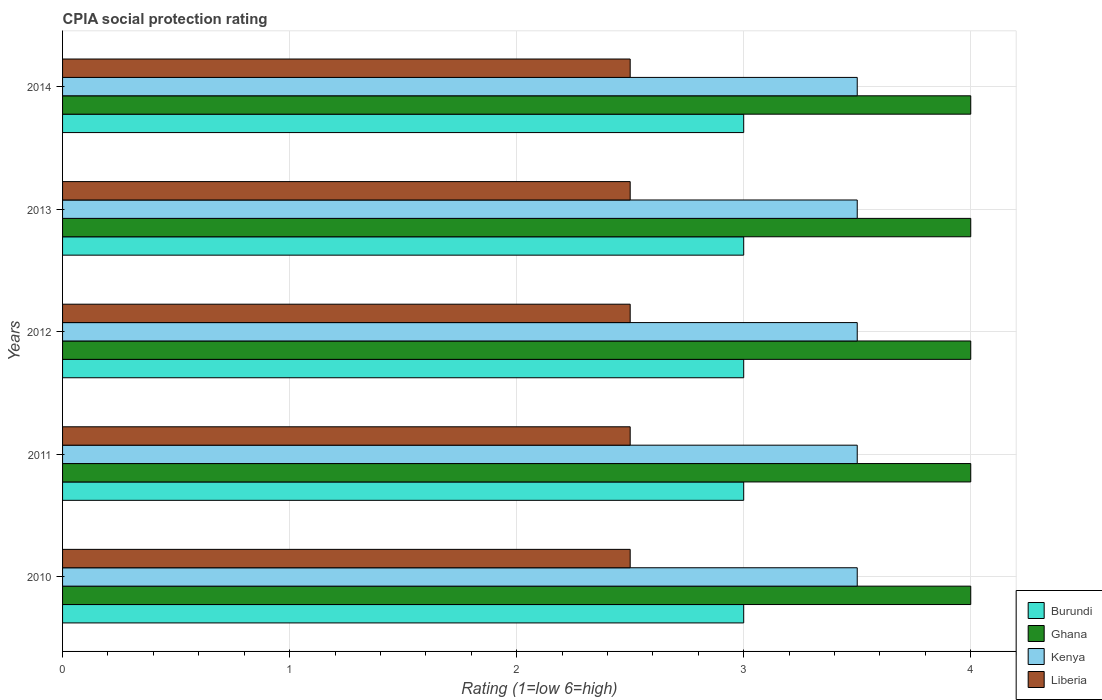How many different coloured bars are there?
Ensure brevity in your answer.  4. How many groups of bars are there?
Make the answer very short. 5. Are the number of bars per tick equal to the number of legend labels?
Make the answer very short. Yes. Are the number of bars on each tick of the Y-axis equal?
Offer a very short reply. Yes. How many bars are there on the 1st tick from the top?
Make the answer very short. 4. Across all years, what is the maximum CPIA rating in Ghana?
Give a very brief answer. 4. In which year was the CPIA rating in Liberia maximum?
Offer a very short reply. 2010. What is the total CPIA rating in Kenya in the graph?
Your answer should be very brief. 17.5. What is the difference between the CPIA rating in Kenya in 2011 and the CPIA rating in Ghana in 2014?
Your answer should be compact. -0.5. What is the average CPIA rating in Burundi per year?
Keep it short and to the point. 3. In how many years, is the CPIA rating in Ghana greater than 2.4 ?
Your answer should be compact. 5. What is the difference between the highest and the second highest CPIA rating in Ghana?
Make the answer very short. 0. What is the difference between the highest and the lowest CPIA rating in Ghana?
Keep it short and to the point. 0. In how many years, is the CPIA rating in Kenya greater than the average CPIA rating in Kenya taken over all years?
Your answer should be very brief. 0. Is the sum of the CPIA rating in Kenya in 2012 and 2013 greater than the maximum CPIA rating in Liberia across all years?
Keep it short and to the point. Yes. What does the 2nd bar from the top in 2011 represents?
Ensure brevity in your answer.  Kenya. What does the 1st bar from the bottom in 2011 represents?
Offer a very short reply. Burundi. How many bars are there?
Provide a succinct answer. 20. How many years are there in the graph?
Offer a very short reply. 5. Does the graph contain any zero values?
Provide a succinct answer. No. Does the graph contain grids?
Your response must be concise. Yes. How many legend labels are there?
Make the answer very short. 4. How are the legend labels stacked?
Ensure brevity in your answer.  Vertical. What is the title of the graph?
Make the answer very short. CPIA social protection rating. What is the label or title of the X-axis?
Your answer should be compact. Rating (1=low 6=high). What is the label or title of the Y-axis?
Offer a terse response. Years. What is the Rating (1=low 6=high) of Burundi in 2010?
Give a very brief answer. 3. What is the Rating (1=low 6=high) in Ghana in 2010?
Offer a terse response. 4. What is the Rating (1=low 6=high) of Kenya in 2010?
Give a very brief answer. 3.5. What is the Rating (1=low 6=high) in Burundi in 2011?
Your response must be concise. 3. What is the Rating (1=low 6=high) in Ghana in 2011?
Your response must be concise. 4. What is the Rating (1=low 6=high) of Ghana in 2012?
Ensure brevity in your answer.  4. What is the Rating (1=low 6=high) of Kenya in 2013?
Keep it short and to the point. 3.5. What is the Rating (1=low 6=high) in Liberia in 2013?
Provide a short and direct response. 2.5. What is the Rating (1=low 6=high) in Liberia in 2014?
Ensure brevity in your answer.  2.5. Across all years, what is the maximum Rating (1=low 6=high) of Kenya?
Your answer should be very brief. 3.5. Across all years, what is the minimum Rating (1=low 6=high) of Burundi?
Give a very brief answer. 3. Across all years, what is the minimum Rating (1=low 6=high) in Ghana?
Your answer should be compact. 4. Across all years, what is the minimum Rating (1=low 6=high) in Kenya?
Offer a very short reply. 3.5. Across all years, what is the minimum Rating (1=low 6=high) in Liberia?
Your answer should be compact. 2.5. What is the total Rating (1=low 6=high) of Burundi in the graph?
Your response must be concise. 15. What is the total Rating (1=low 6=high) in Ghana in the graph?
Give a very brief answer. 20. What is the total Rating (1=low 6=high) in Kenya in the graph?
Provide a short and direct response. 17.5. What is the difference between the Rating (1=low 6=high) in Burundi in 2010 and that in 2011?
Provide a succinct answer. 0. What is the difference between the Rating (1=low 6=high) in Ghana in 2010 and that in 2011?
Offer a terse response. 0. What is the difference between the Rating (1=low 6=high) in Kenya in 2010 and that in 2011?
Provide a succinct answer. 0. What is the difference between the Rating (1=low 6=high) in Liberia in 2010 and that in 2011?
Keep it short and to the point. 0. What is the difference between the Rating (1=low 6=high) in Burundi in 2010 and that in 2012?
Provide a succinct answer. 0. What is the difference between the Rating (1=low 6=high) in Ghana in 2010 and that in 2013?
Provide a succinct answer. 0. What is the difference between the Rating (1=low 6=high) in Ghana in 2010 and that in 2014?
Offer a terse response. 0. What is the difference between the Rating (1=low 6=high) of Kenya in 2010 and that in 2014?
Your answer should be compact. 0. What is the difference between the Rating (1=low 6=high) of Burundi in 2011 and that in 2012?
Your answer should be very brief. 0. What is the difference between the Rating (1=low 6=high) of Liberia in 2011 and that in 2012?
Ensure brevity in your answer.  0. What is the difference between the Rating (1=low 6=high) in Burundi in 2011 and that in 2014?
Your response must be concise. 0. What is the difference between the Rating (1=low 6=high) in Kenya in 2011 and that in 2014?
Offer a very short reply. 0. What is the difference between the Rating (1=low 6=high) of Liberia in 2011 and that in 2014?
Ensure brevity in your answer.  0. What is the difference between the Rating (1=low 6=high) in Burundi in 2012 and that in 2013?
Ensure brevity in your answer.  0. What is the difference between the Rating (1=low 6=high) in Kenya in 2012 and that in 2013?
Your response must be concise. 0. What is the difference between the Rating (1=low 6=high) in Kenya in 2012 and that in 2014?
Your answer should be very brief. 0. What is the difference between the Rating (1=low 6=high) in Liberia in 2012 and that in 2014?
Ensure brevity in your answer.  0. What is the difference between the Rating (1=low 6=high) in Burundi in 2013 and that in 2014?
Ensure brevity in your answer.  0. What is the difference between the Rating (1=low 6=high) of Kenya in 2013 and that in 2014?
Provide a succinct answer. 0. What is the difference between the Rating (1=low 6=high) of Burundi in 2010 and the Rating (1=low 6=high) of Kenya in 2011?
Offer a very short reply. -0.5. What is the difference between the Rating (1=low 6=high) of Burundi in 2010 and the Rating (1=low 6=high) of Liberia in 2011?
Provide a succinct answer. 0.5. What is the difference between the Rating (1=low 6=high) of Kenya in 2010 and the Rating (1=low 6=high) of Liberia in 2011?
Keep it short and to the point. 1. What is the difference between the Rating (1=low 6=high) of Burundi in 2010 and the Rating (1=low 6=high) of Kenya in 2012?
Your response must be concise. -0.5. What is the difference between the Rating (1=low 6=high) in Ghana in 2010 and the Rating (1=low 6=high) in Liberia in 2012?
Your answer should be compact. 1.5. What is the difference between the Rating (1=low 6=high) of Burundi in 2010 and the Rating (1=low 6=high) of Ghana in 2013?
Offer a very short reply. -1. What is the difference between the Rating (1=low 6=high) of Ghana in 2010 and the Rating (1=low 6=high) of Kenya in 2013?
Offer a very short reply. 0.5. What is the difference between the Rating (1=low 6=high) of Burundi in 2010 and the Rating (1=low 6=high) of Ghana in 2014?
Ensure brevity in your answer.  -1. What is the difference between the Rating (1=low 6=high) of Burundi in 2010 and the Rating (1=low 6=high) of Kenya in 2014?
Offer a terse response. -0.5. What is the difference between the Rating (1=low 6=high) of Burundi in 2010 and the Rating (1=low 6=high) of Liberia in 2014?
Make the answer very short. 0.5. What is the difference between the Rating (1=low 6=high) in Ghana in 2010 and the Rating (1=low 6=high) in Kenya in 2014?
Keep it short and to the point. 0.5. What is the difference between the Rating (1=low 6=high) of Kenya in 2010 and the Rating (1=low 6=high) of Liberia in 2014?
Your response must be concise. 1. What is the difference between the Rating (1=low 6=high) in Burundi in 2011 and the Rating (1=low 6=high) in Ghana in 2012?
Provide a succinct answer. -1. What is the difference between the Rating (1=low 6=high) in Burundi in 2011 and the Rating (1=low 6=high) in Liberia in 2012?
Your answer should be very brief. 0.5. What is the difference between the Rating (1=low 6=high) of Ghana in 2011 and the Rating (1=low 6=high) of Kenya in 2012?
Give a very brief answer. 0.5. What is the difference between the Rating (1=low 6=high) of Ghana in 2011 and the Rating (1=low 6=high) of Liberia in 2012?
Offer a terse response. 1.5. What is the difference between the Rating (1=low 6=high) in Burundi in 2011 and the Rating (1=low 6=high) in Ghana in 2013?
Give a very brief answer. -1. What is the difference between the Rating (1=low 6=high) in Burundi in 2011 and the Rating (1=low 6=high) in Kenya in 2013?
Keep it short and to the point. -0.5. What is the difference between the Rating (1=low 6=high) of Kenya in 2011 and the Rating (1=low 6=high) of Liberia in 2013?
Offer a terse response. 1. What is the difference between the Rating (1=low 6=high) of Burundi in 2011 and the Rating (1=low 6=high) of Ghana in 2014?
Provide a succinct answer. -1. What is the difference between the Rating (1=low 6=high) in Burundi in 2011 and the Rating (1=low 6=high) in Kenya in 2014?
Provide a succinct answer. -0.5. What is the difference between the Rating (1=low 6=high) of Burundi in 2011 and the Rating (1=low 6=high) of Liberia in 2014?
Keep it short and to the point. 0.5. What is the difference between the Rating (1=low 6=high) of Ghana in 2011 and the Rating (1=low 6=high) of Kenya in 2014?
Give a very brief answer. 0.5. What is the difference between the Rating (1=low 6=high) of Kenya in 2011 and the Rating (1=low 6=high) of Liberia in 2014?
Provide a short and direct response. 1. What is the difference between the Rating (1=low 6=high) in Burundi in 2012 and the Rating (1=low 6=high) in Ghana in 2013?
Your answer should be compact. -1. What is the difference between the Rating (1=low 6=high) in Burundi in 2012 and the Rating (1=low 6=high) in Kenya in 2013?
Offer a very short reply. -0.5. What is the difference between the Rating (1=low 6=high) of Ghana in 2012 and the Rating (1=low 6=high) of Kenya in 2013?
Your answer should be compact. 0.5. What is the difference between the Rating (1=low 6=high) in Ghana in 2012 and the Rating (1=low 6=high) in Liberia in 2013?
Provide a short and direct response. 1.5. What is the difference between the Rating (1=low 6=high) in Burundi in 2012 and the Rating (1=low 6=high) in Ghana in 2014?
Your response must be concise. -1. What is the difference between the Rating (1=low 6=high) in Burundi in 2012 and the Rating (1=low 6=high) in Kenya in 2014?
Provide a succinct answer. -0.5. What is the difference between the Rating (1=low 6=high) in Burundi in 2012 and the Rating (1=low 6=high) in Liberia in 2014?
Provide a short and direct response. 0.5. What is the difference between the Rating (1=low 6=high) of Ghana in 2012 and the Rating (1=low 6=high) of Kenya in 2014?
Provide a succinct answer. 0.5. What is the difference between the Rating (1=low 6=high) in Kenya in 2012 and the Rating (1=low 6=high) in Liberia in 2014?
Ensure brevity in your answer.  1. What is the difference between the Rating (1=low 6=high) of Burundi in 2013 and the Rating (1=low 6=high) of Ghana in 2014?
Provide a succinct answer. -1. What is the difference between the Rating (1=low 6=high) in Burundi in 2013 and the Rating (1=low 6=high) in Kenya in 2014?
Provide a succinct answer. -0.5. What is the difference between the Rating (1=low 6=high) of Burundi in 2013 and the Rating (1=low 6=high) of Liberia in 2014?
Provide a short and direct response. 0.5. What is the difference between the Rating (1=low 6=high) of Ghana in 2013 and the Rating (1=low 6=high) of Liberia in 2014?
Ensure brevity in your answer.  1.5. What is the average Rating (1=low 6=high) in Ghana per year?
Ensure brevity in your answer.  4. In the year 2010, what is the difference between the Rating (1=low 6=high) in Burundi and Rating (1=low 6=high) in Ghana?
Give a very brief answer. -1. In the year 2010, what is the difference between the Rating (1=low 6=high) in Burundi and Rating (1=low 6=high) in Kenya?
Keep it short and to the point. -0.5. In the year 2011, what is the difference between the Rating (1=low 6=high) of Kenya and Rating (1=low 6=high) of Liberia?
Keep it short and to the point. 1. In the year 2012, what is the difference between the Rating (1=low 6=high) of Burundi and Rating (1=low 6=high) of Kenya?
Your answer should be very brief. -0.5. In the year 2012, what is the difference between the Rating (1=low 6=high) of Burundi and Rating (1=low 6=high) of Liberia?
Offer a very short reply. 0.5. In the year 2013, what is the difference between the Rating (1=low 6=high) in Burundi and Rating (1=low 6=high) in Ghana?
Provide a short and direct response. -1. In the year 2013, what is the difference between the Rating (1=low 6=high) of Burundi and Rating (1=low 6=high) of Kenya?
Your answer should be very brief. -0.5. In the year 2013, what is the difference between the Rating (1=low 6=high) of Ghana and Rating (1=low 6=high) of Kenya?
Provide a short and direct response. 0.5. In the year 2013, what is the difference between the Rating (1=low 6=high) of Kenya and Rating (1=low 6=high) of Liberia?
Offer a very short reply. 1. In the year 2014, what is the difference between the Rating (1=low 6=high) in Burundi and Rating (1=low 6=high) in Kenya?
Your answer should be very brief. -0.5. In the year 2014, what is the difference between the Rating (1=low 6=high) in Kenya and Rating (1=low 6=high) in Liberia?
Offer a terse response. 1. What is the ratio of the Rating (1=low 6=high) of Burundi in 2010 to that in 2011?
Give a very brief answer. 1. What is the ratio of the Rating (1=low 6=high) in Kenya in 2010 to that in 2012?
Make the answer very short. 1. What is the ratio of the Rating (1=low 6=high) of Burundi in 2010 to that in 2013?
Ensure brevity in your answer.  1. What is the ratio of the Rating (1=low 6=high) of Liberia in 2010 to that in 2013?
Make the answer very short. 1. What is the ratio of the Rating (1=low 6=high) of Burundi in 2010 to that in 2014?
Provide a short and direct response. 1. What is the ratio of the Rating (1=low 6=high) in Kenya in 2010 to that in 2014?
Provide a short and direct response. 1. What is the ratio of the Rating (1=low 6=high) in Ghana in 2011 to that in 2012?
Your answer should be very brief. 1. What is the ratio of the Rating (1=low 6=high) of Liberia in 2011 to that in 2012?
Offer a terse response. 1. What is the ratio of the Rating (1=low 6=high) of Burundi in 2011 to that in 2013?
Make the answer very short. 1. What is the ratio of the Rating (1=low 6=high) of Ghana in 2011 to that in 2013?
Your answer should be compact. 1. What is the ratio of the Rating (1=low 6=high) of Liberia in 2011 to that in 2013?
Your response must be concise. 1. What is the ratio of the Rating (1=low 6=high) in Burundi in 2011 to that in 2014?
Provide a short and direct response. 1. What is the ratio of the Rating (1=low 6=high) of Kenya in 2011 to that in 2014?
Provide a succinct answer. 1. What is the ratio of the Rating (1=low 6=high) of Burundi in 2012 to that in 2013?
Your answer should be very brief. 1. What is the ratio of the Rating (1=low 6=high) of Ghana in 2012 to that in 2013?
Your answer should be very brief. 1. What is the ratio of the Rating (1=low 6=high) in Ghana in 2012 to that in 2014?
Ensure brevity in your answer.  1. What is the ratio of the Rating (1=low 6=high) of Kenya in 2012 to that in 2014?
Your answer should be compact. 1. What is the ratio of the Rating (1=low 6=high) in Ghana in 2013 to that in 2014?
Provide a succinct answer. 1. What is the ratio of the Rating (1=low 6=high) of Liberia in 2013 to that in 2014?
Your response must be concise. 1. What is the difference between the highest and the second highest Rating (1=low 6=high) of Burundi?
Your response must be concise. 0. What is the difference between the highest and the second highest Rating (1=low 6=high) in Kenya?
Offer a terse response. 0. What is the difference between the highest and the second highest Rating (1=low 6=high) of Liberia?
Provide a succinct answer. 0. What is the difference between the highest and the lowest Rating (1=low 6=high) of Kenya?
Offer a terse response. 0. 